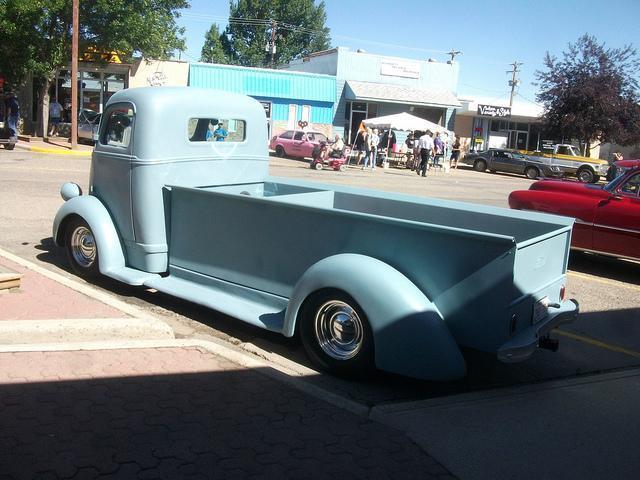What color is the strange old truck?
From the following four choices, select the correct answer to address the question.
Options: Turquoise, red, pink, gray. Turquoise. 